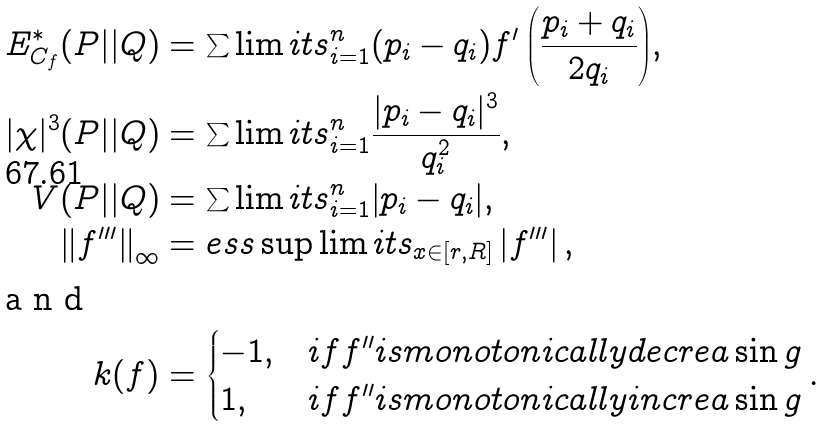<formula> <loc_0><loc_0><loc_500><loc_500>E _ { C _ { f } } ^ { \ast } ( P | | Q ) & = \sum \lim i t s _ { i = 1 } ^ { n } { ( p _ { i } - q _ { i } ) { f } ^ { \prime } \left ( { \frac { p _ { i } + q _ { i } } { 2 q _ { i } } } \right ) } , \\ | \chi | ^ { 3 } ( P | | Q ) & = \sum \lim i t s _ { i = 1 } ^ { n } { \frac { | p _ { i } - q _ { i } | ^ { 3 } } { q _ { i } ^ { 2 } } } , \\ V ( P | | Q ) & = \sum \lim i t s _ { i = 1 } ^ { n } { \left | { p _ { i } - q _ { i } } \right | } , \\ \left \| { f } ^ { \prime \prime \prime } \right \| _ { \infty } & = e s s \sup \lim i t s _ { x \in [ r , R ] } \left | { f } ^ { \prime \prime \prime } \right | , \\ \intertext { a n d } k ( f ) & = \begin{cases} { - 1 , } & { i f { f } ^ { \prime \prime } i s m o n o t o n i c a l l y d e c r e a \sin g } \\ { 1 , } & { i f { f } ^ { \prime \prime } i s m o n o t o n i c a l l y i n c r e a \sin g } \\ \end{cases} .</formula> 